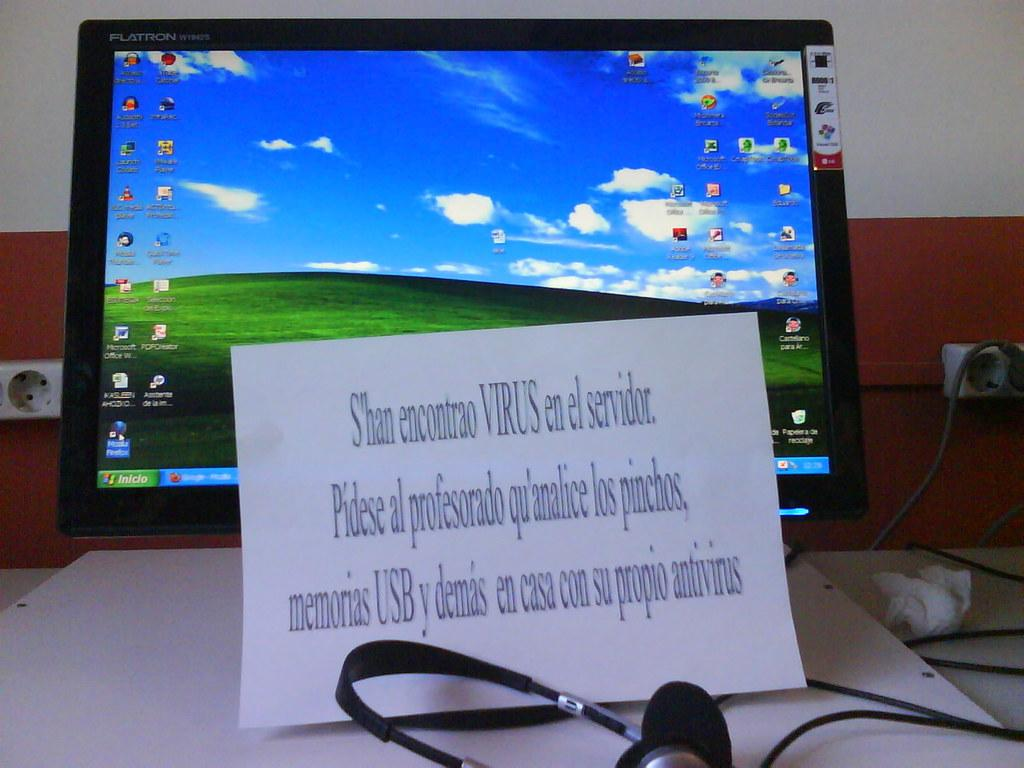What electronic device is present in the image? There is a monitor in the image. What accessory is visible near the monitor? There are headphones in the image. What type of written material can be seen in the image? There is a paper with words written on it in the image. What can be seen in the background of the image? There is a wall and switch sockets visible in the background of the image. Can you see any seeds growing on the wall in the image? There are no seeds visible in the image; the wall is part of the background and does not show any signs of growth. 